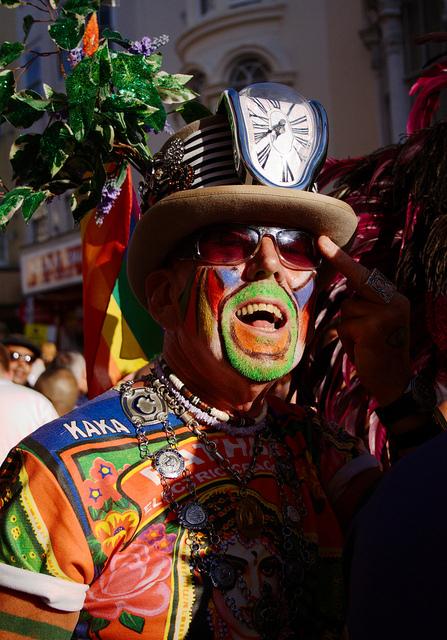What letters are written on the man's right shoulder?
Short answer required. Kaka. Is the man happy?
Give a very brief answer. Yes. Where is the clock in the photo?
Write a very short answer. On hat. 